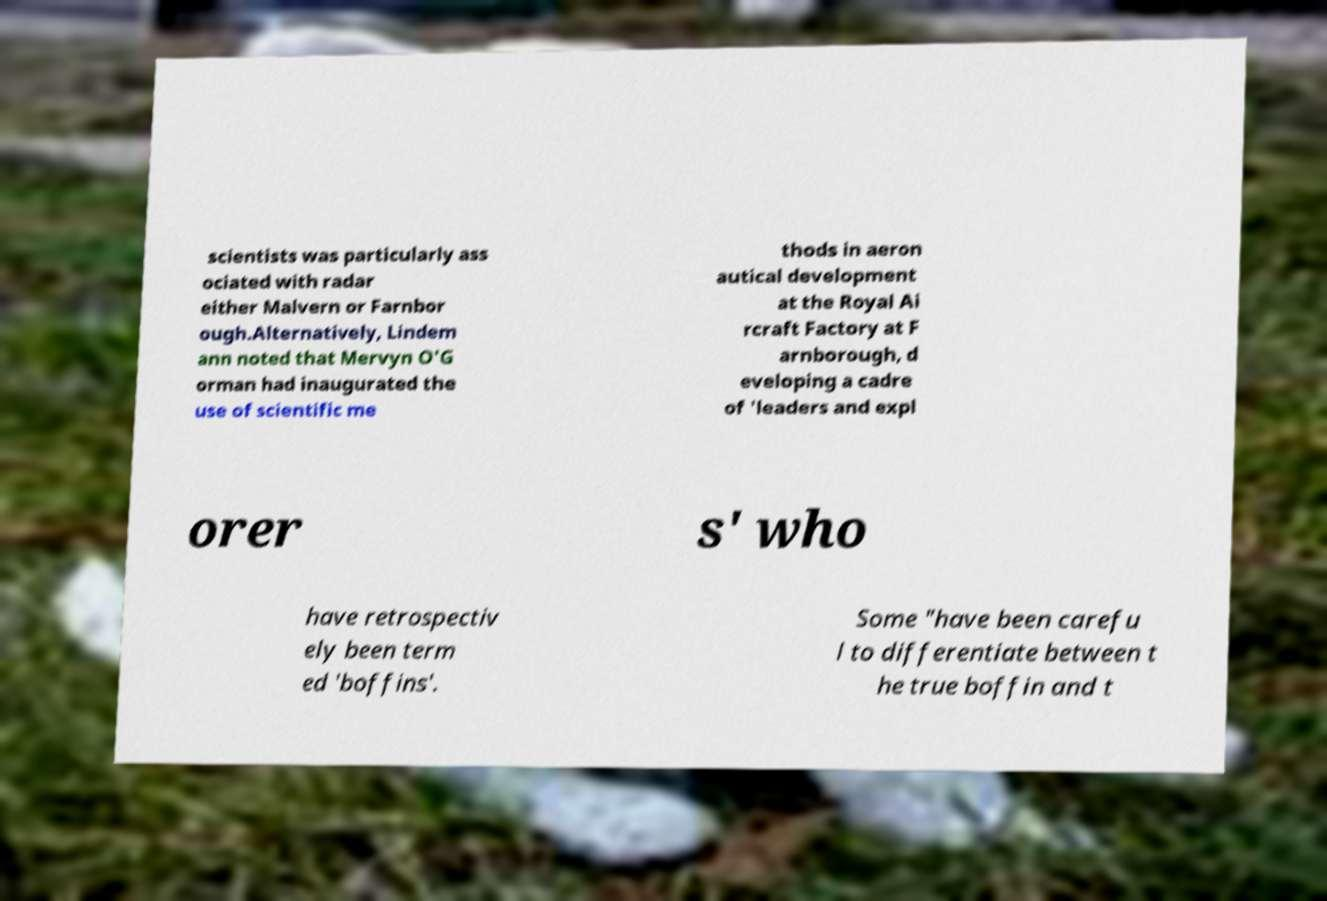What messages or text are displayed in this image? I need them in a readable, typed format. scientists was particularly ass ociated with radar either Malvern or Farnbor ough.Alternatively, Lindem ann noted that Mervyn O'G orman had inaugurated the use of scientific me thods in aeron autical development at the Royal Ai rcraft Factory at F arnborough, d eveloping a cadre of 'leaders and expl orer s' who have retrospectiv ely been term ed 'boffins'. Some "have been carefu l to differentiate between t he true boffin and t 